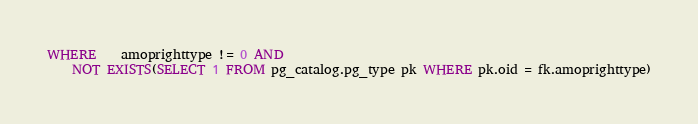<code> <loc_0><loc_0><loc_500><loc_500><_SQL_>WHERE	amoprighttype != 0 AND
	NOT EXISTS(SELECT 1 FROM pg_catalog.pg_type pk WHERE pk.oid = fk.amoprighttype)
</code> 